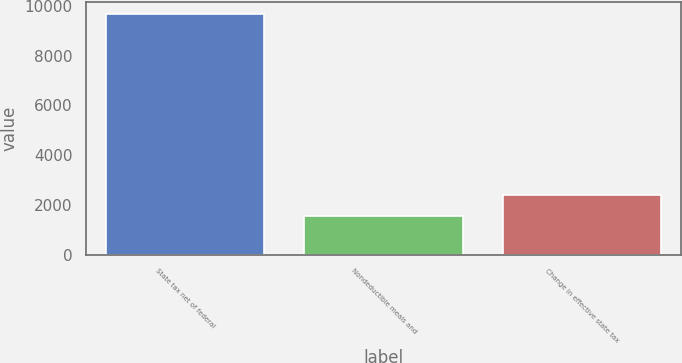<chart> <loc_0><loc_0><loc_500><loc_500><bar_chart><fcel>State tax net of federal<fcel>Nondeductible meals and<fcel>Change in effective state tax<nl><fcel>9668<fcel>1570<fcel>2379.8<nl></chart> 